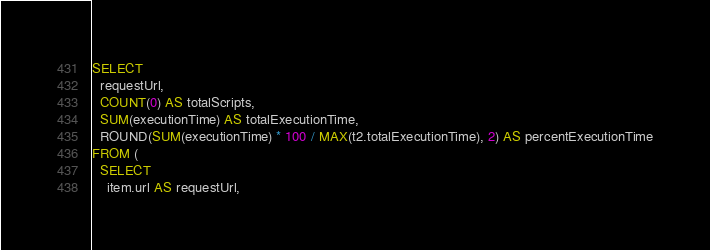<code> <loc_0><loc_0><loc_500><loc_500><_SQL_>SELECT
  requestUrl,
  COUNT(0) AS totalScripts,
  SUM(executionTime) AS totalExecutionTime,
  ROUND(SUM(executionTime) * 100 / MAX(t2.totalExecutionTime), 2) AS percentExecutionTime
FROM (
  SELECT
    item.url AS requestUrl,</code> 